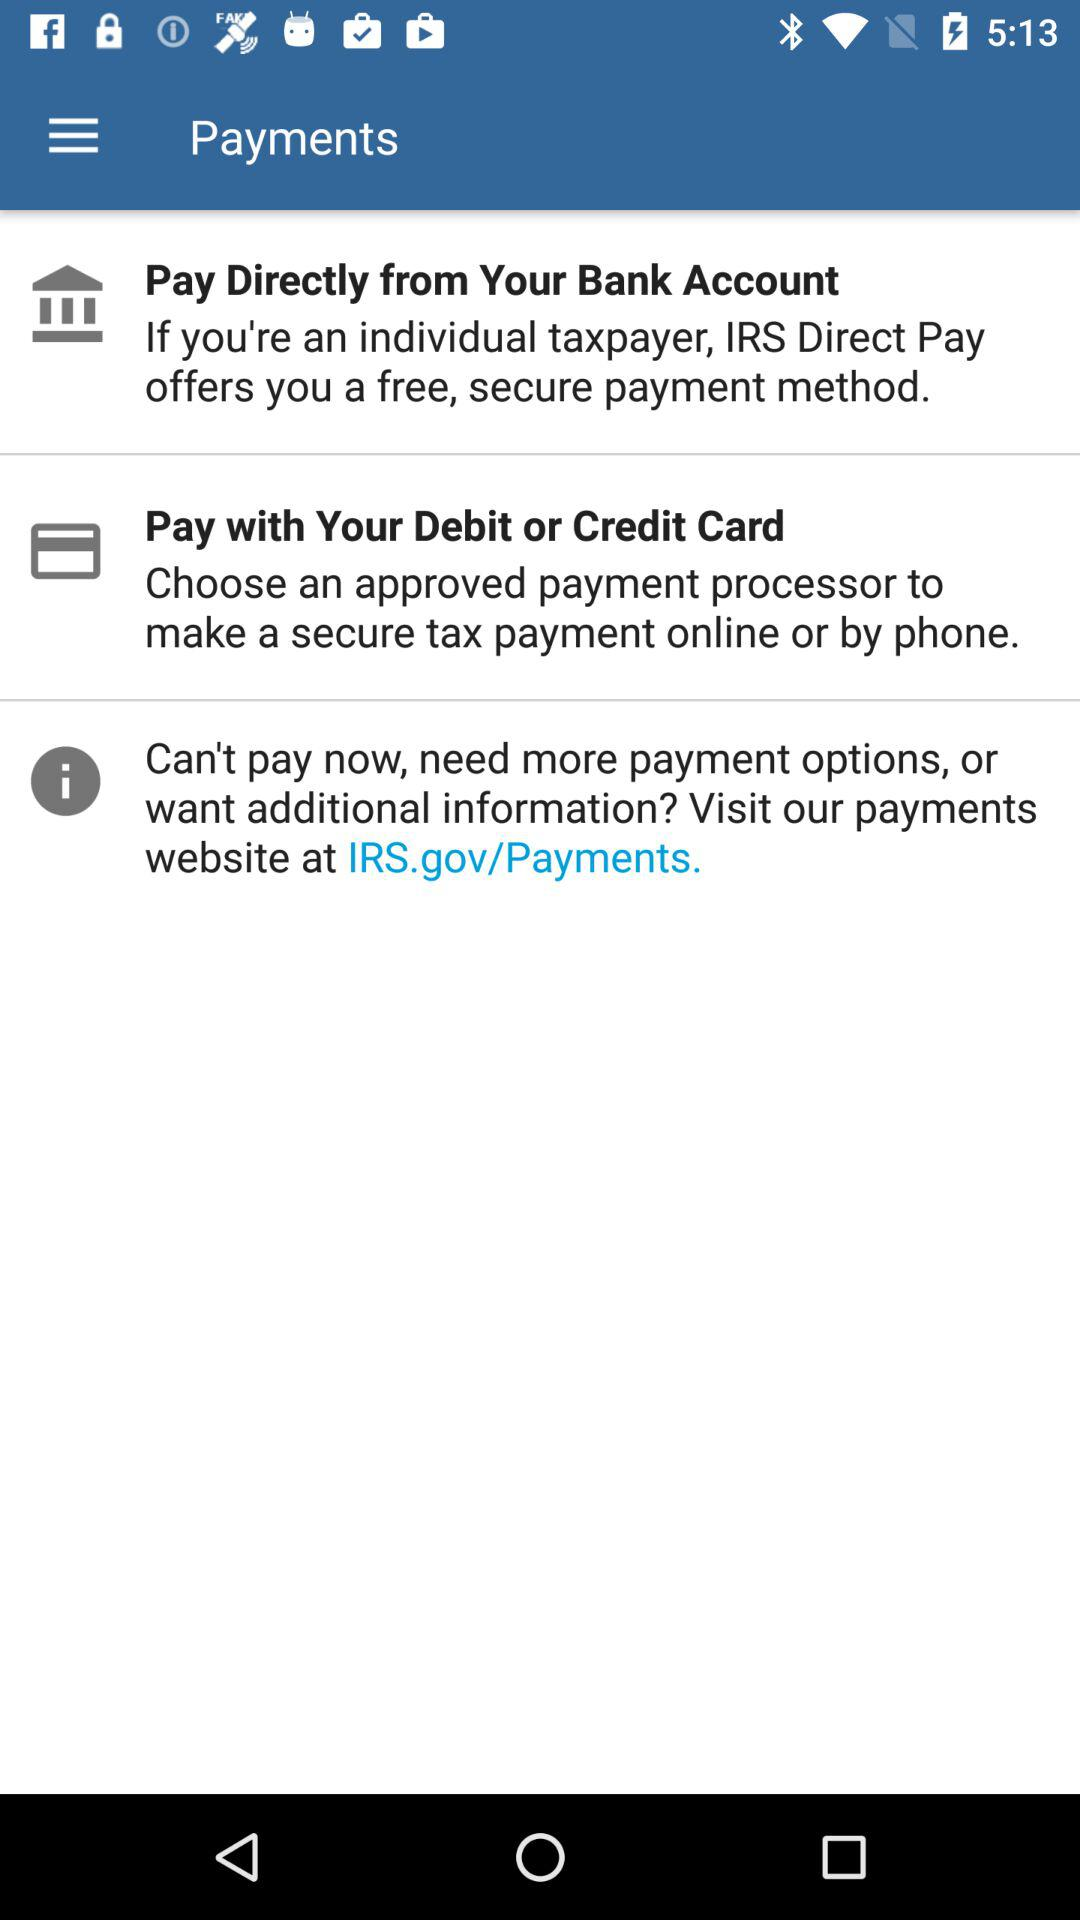What is the website address for additional information? The website address is IRS.gov/Payments. 